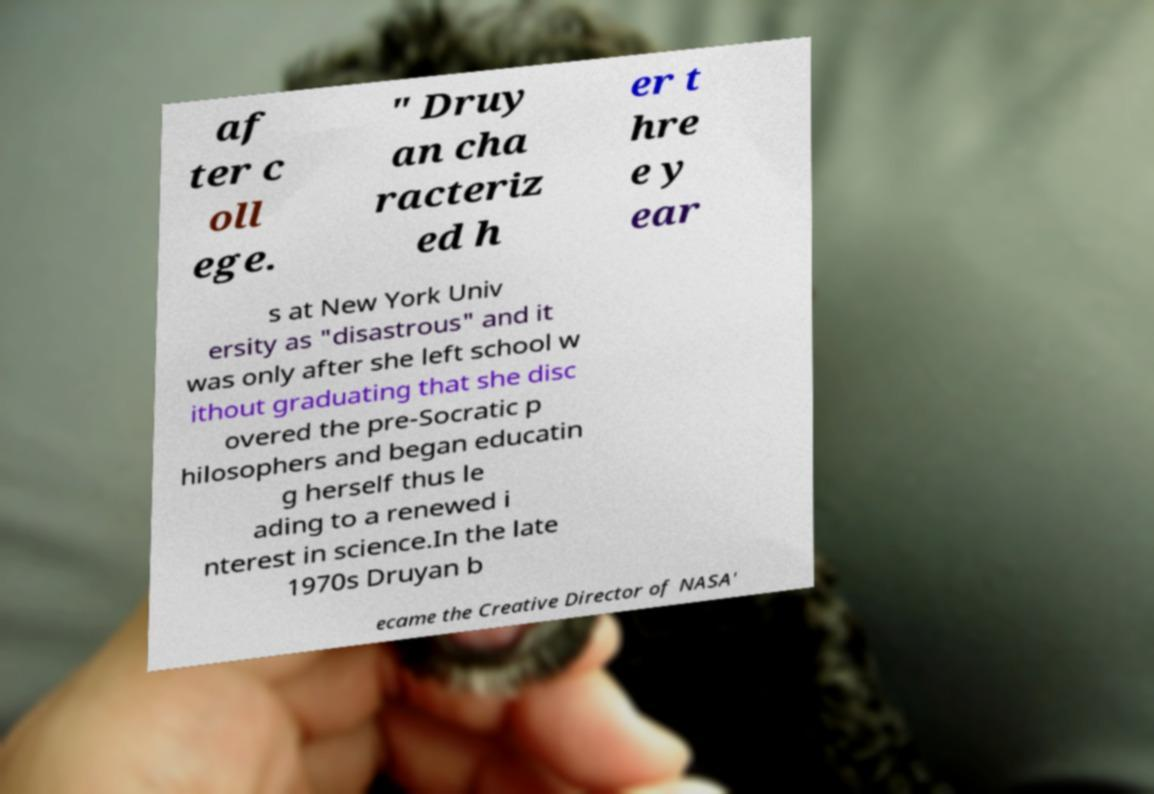Could you extract and type out the text from this image? af ter c oll ege. " Druy an cha racteriz ed h er t hre e y ear s at New York Univ ersity as "disastrous" and it was only after she left school w ithout graduating that she disc overed the pre-Socratic p hilosophers and began educatin g herself thus le ading to a renewed i nterest in science.In the late 1970s Druyan b ecame the Creative Director of NASA' 